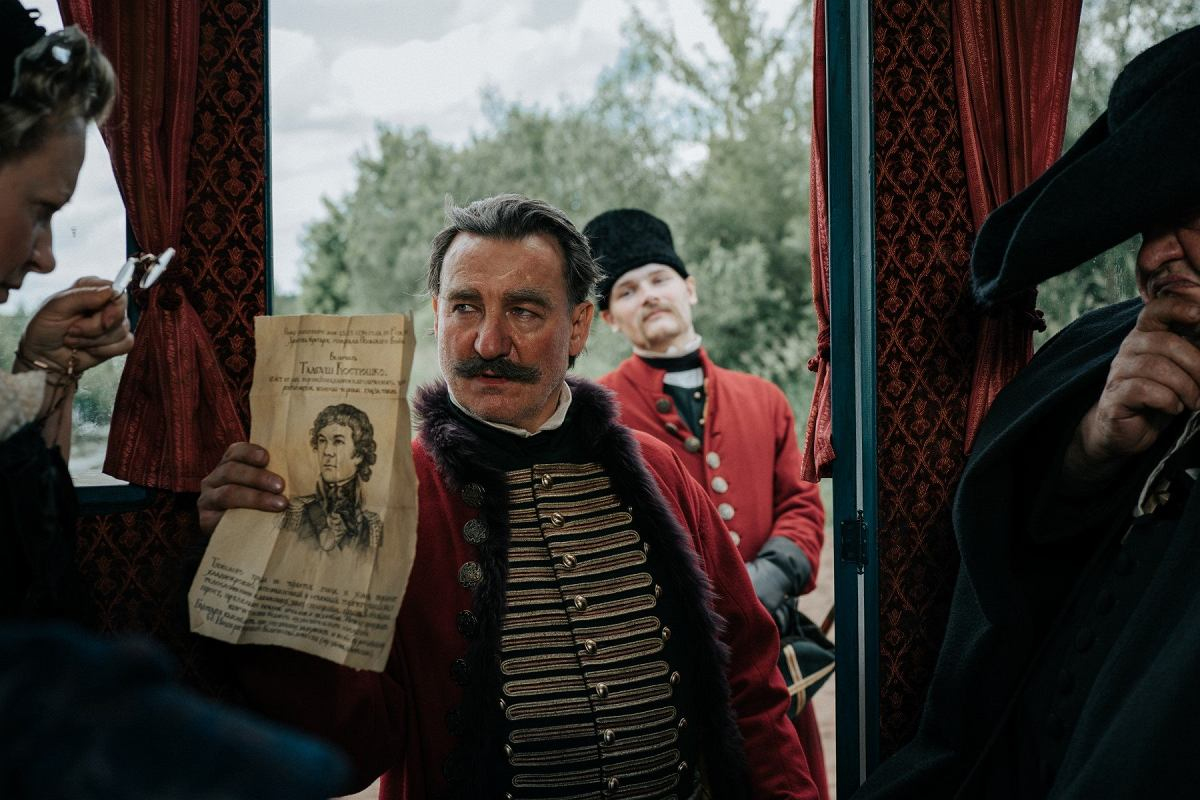What might the portrait on the paper represent in this historical scene? The portrait likely represents a key figure relevant to the narrative or historical context depicted. It could be a famous historical leader, a loved one, or a figure of political importance at the time. The presence of the portrait suggests it might be a motivational or influential element for the characters involved, possibly driving the plot or symbolizing important themes such as loyalty, heritage, or conflict. 